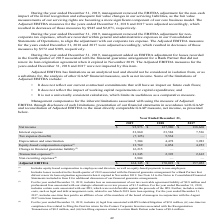From Greensky's financial document, Which years does the table show? The document contains multiple relevant values: 2019, 2018, 2017. From the document: "easures for the years ended December 31, 2018 and 2017 were not impacted by this item. During the year ended December 31, 2019, management added an EB..." Also, What was the net income in 2019? According to the financial document, 95,973 (in thousands). The relevant text states: "Net income $ 95,973 $ 127,980 $ 138,668..." Also, What was the interest expense in 2018? According to the financial document, 23,584 (in thousands). The relevant text states: "Interest expense 23,860 23,584 7,536..." Also, How many years did net income exceed $100,000 thousand? Counting the relevant items in the document: 2018, 2017, I find 2 instances. The key data points involved are: 2017, 2018. Also, can you calculate: What was the change in the interest expense between 2017 and 2018? Based on the calculation: 23,584-7,536, the result is 16048 (in thousands). This is based on the information: "Interest expense 23,860 23,584 7,536 Interest expense 23,860 23,584 7,536..." The key data points involved are: 23,584, 7,536. Also, can you calculate: What was the percentage change in Depreciation and amortization between 2018 and 2019? To answer this question, I need to perform calculations using the financial data. The calculation is: (7,304-4,478)/4,478, which equals 63.11 (percentage). This is based on the information: "Depreciation and amortization 7,304 4,478 3,983 Depreciation and amortization 7,304 4,478 3,983..." The key data points involved are: 4,478, 7,304. 